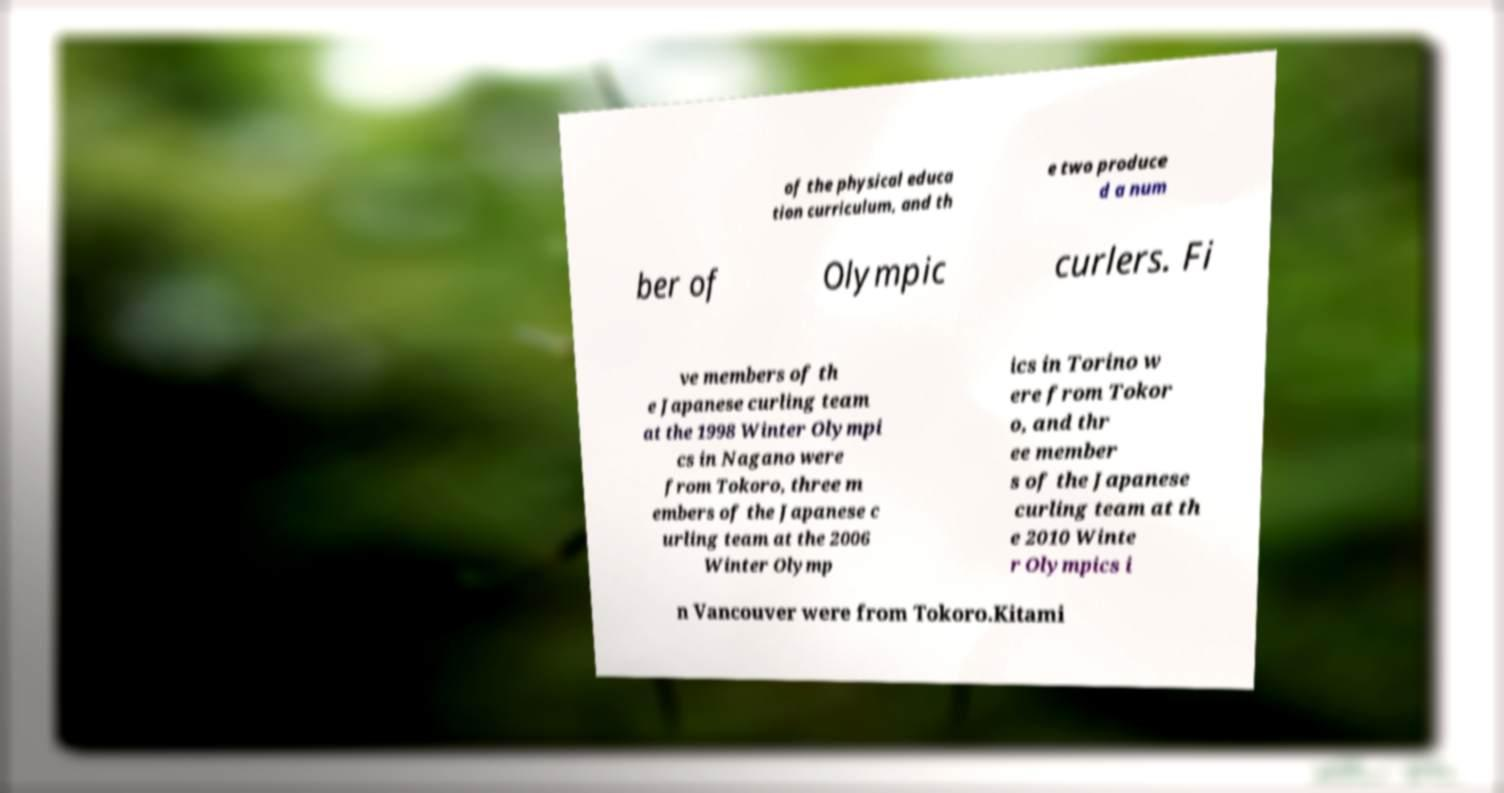Can you read and provide the text displayed in the image?This photo seems to have some interesting text. Can you extract and type it out for me? of the physical educa tion curriculum, and th e two produce d a num ber of Olympic curlers. Fi ve members of th e Japanese curling team at the 1998 Winter Olympi cs in Nagano were from Tokoro, three m embers of the Japanese c urling team at the 2006 Winter Olymp ics in Torino w ere from Tokor o, and thr ee member s of the Japanese curling team at th e 2010 Winte r Olympics i n Vancouver were from Tokoro.Kitami 